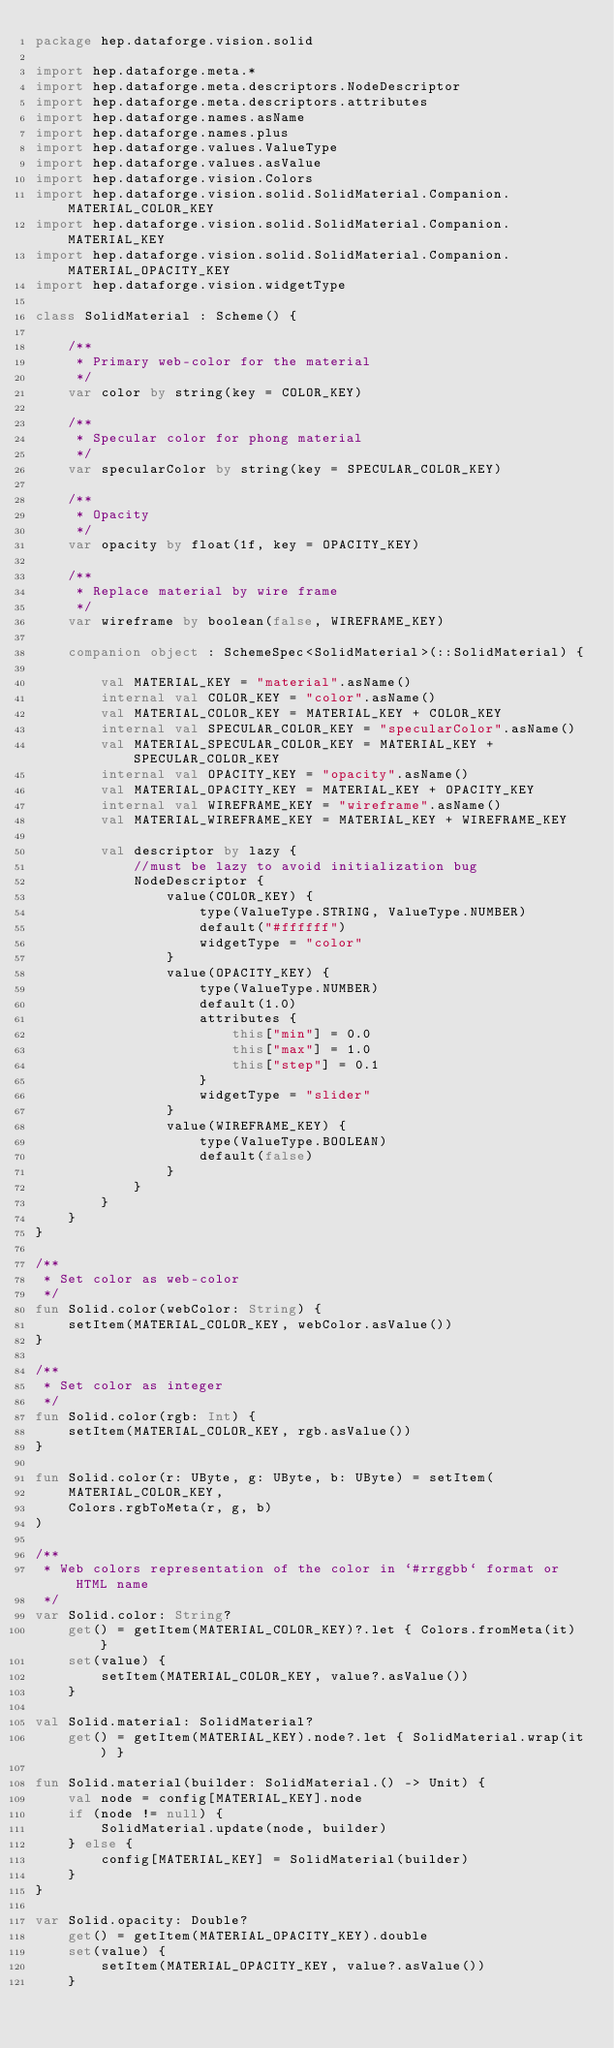Convert code to text. <code><loc_0><loc_0><loc_500><loc_500><_Kotlin_>package hep.dataforge.vision.solid

import hep.dataforge.meta.*
import hep.dataforge.meta.descriptors.NodeDescriptor
import hep.dataforge.meta.descriptors.attributes
import hep.dataforge.names.asName
import hep.dataforge.names.plus
import hep.dataforge.values.ValueType
import hep.dataforge.values.asValue
import hep.dataforge.vision.Colors
import hep.dataforge.vision.solid.SolidMaterial.Companion.MATERIAL_COLOR_KEY
import hep.dataforge.vision.solid.SolidMaterial.Companion.MATERIAL_KEY
import hep.dataforge.vision.solid.SolidMaterial.Companion.MATERIAL_OPACITY_KEY
import hep.dataforge.vision.widgetType

class SolidMaterial : Scheme() {

    /**
     * Primary web-color for the material
     */
    var color by string(key = COLOR_KEY)

    /**
     * Specular color for phong material
     */
    var specularColor by string(key = SPECULAR_COLOR_KEY)

    /**
     * Opacity
     */
    var opacity by float(1f, key = OPACITY_KEY)

    /**
     * Replace material by wire frame
     */
    var wireframe by boolean(false, WIREFRAME_KEY)

    companion object : SchemeSpec<SolidMaterial>(::SolidMaterial) {

        val MATERIAL_KEY = "material".asName()
        internal val COLOR_KEY = "color".asName()
        val MATERIAL_COLOR_KEY = MATERIAL_KEY + COLOR_KEY
        internal val SPECULAR_COLOR_KEY = "specularColor".asName()
        val MATERIAL_SPECULAR_COLOR_KEY = MATERIAL_KEY + SPECULAR_COLOR_KEY
        internal val OPACITY_KEY = "opacity".asName()
        val MATERIAL_OPACITY_KEY = MATERIAL_KEY + OPACITY_KEY
        internal val WIREFRAME_KEY = "wireframe".asName()
        val MATERIAL_WIREFRAME_KEY = MATERIAL_KEY + WIREFRAME_KEY

        val descriptor by lazy {
            //must be lazy to avoid initialization bug
            NodeDescriptor {
                value(COLOR_KEY) {
                    type(ValueType.STRING, ValueType.NUMBER)
                    default("#ffffff")
                    widgetType = "color"
                }
                value(OPACITY_KEY) {
                    type(ValueType.NUMBER)
                    default(1.0)
                    attributes {
                        this["min"] = 0.0
                        this["max"] = 1.0
                        this["step"] = 0.1
                    }
                    widgetType = "slider"
                }
                value(WIREFRAME_KEY) {
                    type(ValueType.BOOLEAN)
                    default(false)
                }
            }
        }
    }
}

/**
 * Set color as web-color
 */
fun Solid.color(webColor: String) {
    setItem(MATERIAL_COLOR_KEY, webColor.asValue())
}

/**
 * Set color as integer
 */
fun Solid.color(rgb: Int) {
    setItem(MATERIAL_COLOR_KEY, rgb.asValue())
}

fun Solid.color(r: UByte, g: UByte, b: UByte) = setItem(
    MATERIAL_COLOR_KEY,
    Colors.rgbToMeta(r, g, b)
)

/**
 * Web colors representation of the color in `#rrggbb` format or HTML name
 */
var Solid.color: String?
    get() = getItem(MATERIAL_COLOR_KEY)?.let { Colors.fromMeta(it) }
    set(value) {
        setItem(MATERIAL_COLOR_KEY, value?.asValue())
    }

val Solid.material: SolidMaterial?
    get() = getItem(MATERIAL_KEY).node?.let { SolidMaterial.wrap(it) }

fun Solid.material(builder: SolidMaterial.() -> Unit) {
    val node = config[MATERIAL_KEY].node
    if (node != null) {
        SolidMaterial.update(node, builder)
    } else {
        config[MATERIAL_KEY] = SolidMaterial(builder)
    }
}

var Solid.opacity: Double?
    get() = getItem(MATERIAL_OPACITY_KEY).double
    set(value) {
        setItem(MATERIAL_OPACITY_KEY, value?.asValue())
    }</code> 